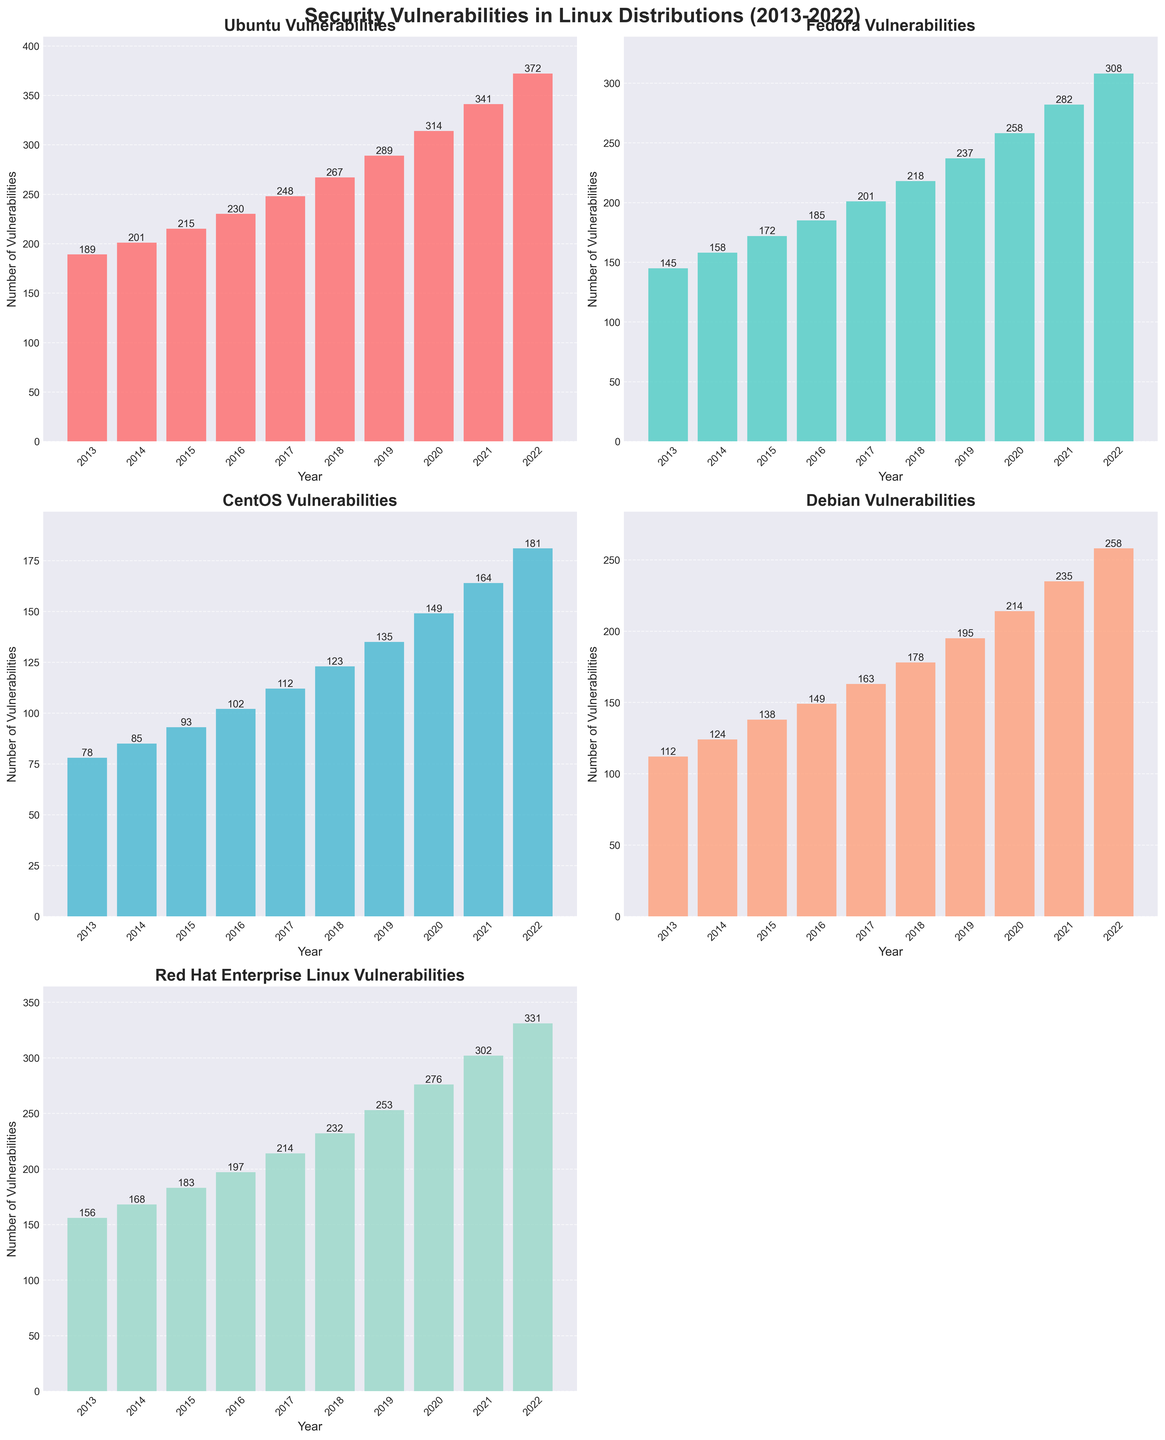What's the trend in the number of security vulnerabilities discovered in Ubuntu over the decade? To identify the trend, examine the height of the bars for Ubuntu from 2013 to 2022. The height consistently increases, indicating an upward trend in the number of vulnerabilities.
Answer: Upward trend Which Linux distribution had the highest number of security vulnerabilities in 2022? Look at the tallest bar for the year 2022 across all subplots. The tallest bar is in the Ubuntu subplot.
Answer: Ubuntu How many more vulnerabilities were discovered in Red Hat Enterprise Linux in 2020 compared to Debian in the same year? Check the bar heights for RHEL and Debian in 2020. RHEL has 276 vulnerabilities and Debian has 214. Subtract Debian's vulnerabilities from RHEL's.
Answer: 62 What was the average number of vulnerabilities for Fedora between 2013 and 2022? Sum up the vulnerabilities for Fedora from 2013 to 2022 and divide by the number of years (10). \((145 + 158 + 172 + 185 + 201 + 218 + 237 + 258 + 282 + 308) / 10 = 216.4\)
Answer: 216.4 Compare the vulnerabilities trend between CentOS and Debian. Are their trends similar or different? Examine the bar trends for both distributions from 2013 to 2022. Both show a steady increase, indicating similar upward trends.
Answer: Similar trends What's the difference in vulnerabilities between the highest and lowest distributions in 2015? Identify the tallest and shortest bars in 2015. Ubuntu has the highest (215) and CentOS has the lowest (93). Subtract the lowest from the highest.
Answer: 122 Was there any year in which Debian had fewer vulnerabilities than CentOS? Compare the bar heights for Debian and CentOS across all years. None of the bars for Debian are shorter than those for CentOS, indicating that Debian always had more or equal vulnerabilities.
Answer: No How did the number of vulnerabilities in Fedora change from 2018 to 2019? Compare the heights of the bars for Fedora between 2018 and 2019. The number of vulnerabilities increased from 218 to 237.
Answer: Increased Which two distributions had nearly the same number of vulnerabilities in 2016? Locate bars with similar heights in 2016. CentOS (102) and Debian (149) are not close, but a closer look at Fedora (185) and Red Hat (197) shows close values.
Answer: Fedora and Red Hat Enterprise Linux What was the cumulative number of vulnerabilities in all distributions in 2021? Add the heights of the bars for all distributions in 2021: \(341 + 282 + 164 + 235 + 302 = 1324\).
Answer: 1324 